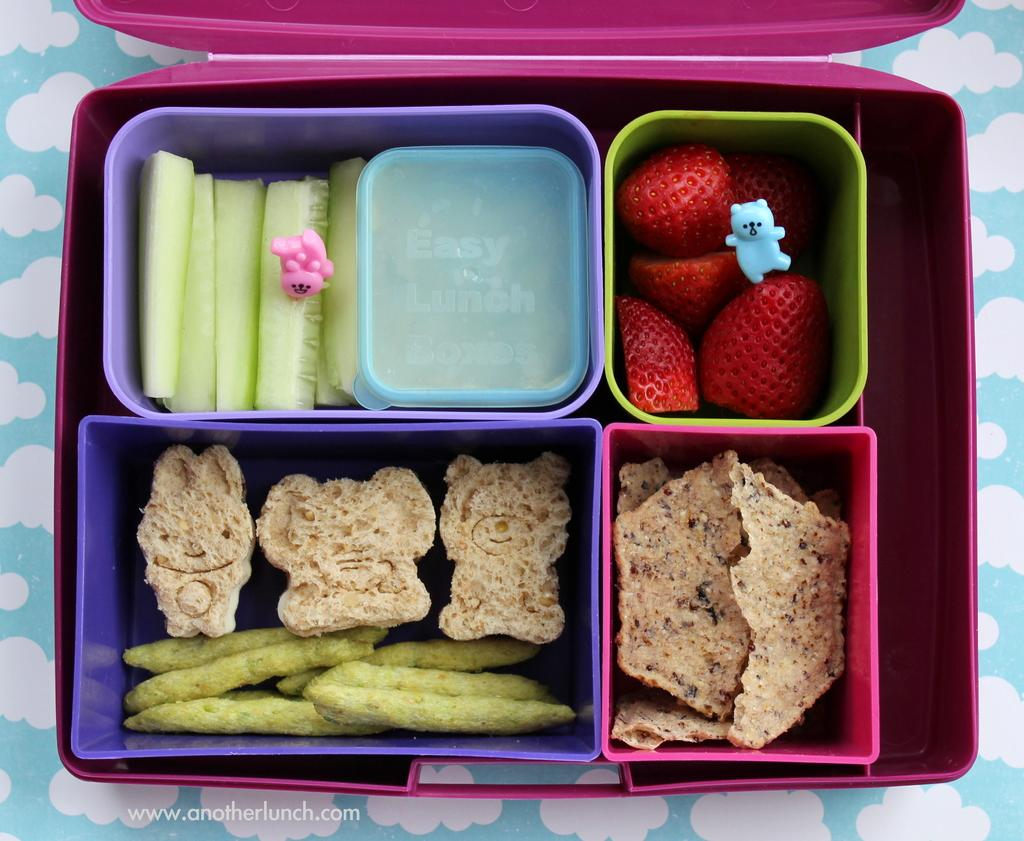What is the color of the box in the image? The box in the image is pink. What is inside the box? The box contains different containers with food items. What type of toys can be seen in the image? There are pink and blue toys in the image. What type of riddle is written on the cover of the box? There is no riddle written on the cover of the box, as the facts provided do not mention any cover or riddle. 